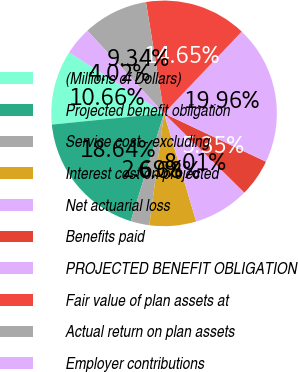<chart> <loc_0><loc_0><loc_500><loc_500><pie_chart><fcel>(Millions of Dollars)<fcel>Projected benefit obligation<fcel>Service cost - excluding<fcel>Interest cost on projected<fcel>Net actuarial loss<fcel>Benefits paid<fcel>PROJECTED BENEFIT OBLIGATION<fcel>Fair value of plan assets at<fcel>Actual return on plan assets<fcel>Employer contributions<nl><fcel>10.66%<fcel>18.64%<fcel>2.69%<fcel>6.68%<fcel>8.01%<fcel>5.35%<fcel>19.96%<fcel>14.65%<fcel>9.34%<fcel>4.02%<nl></chart> 